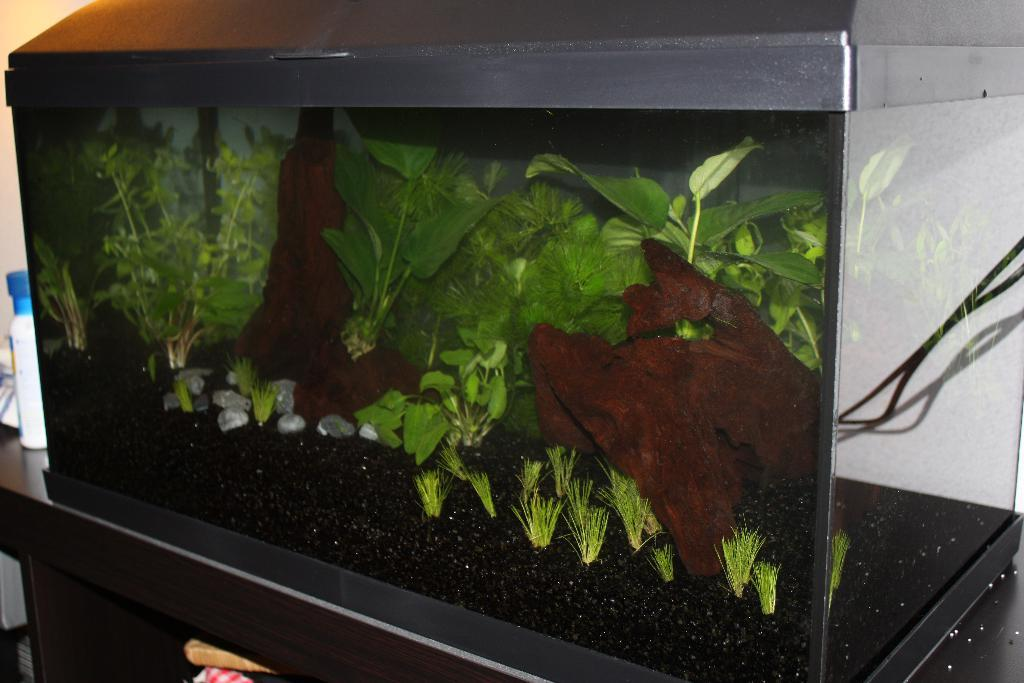What is the main feature of the image? There is an aquarium in the image. What can be found inside the aquarium? There are plants, grass, stones, and black sand in the aquarium. What is the aquarium placed on? The aquarium is on a table. What type of cheese is visible in the image? There is no cheese present in the image. Can you tell me what time it is according to the clock in the image? There is no clock present in the image. 